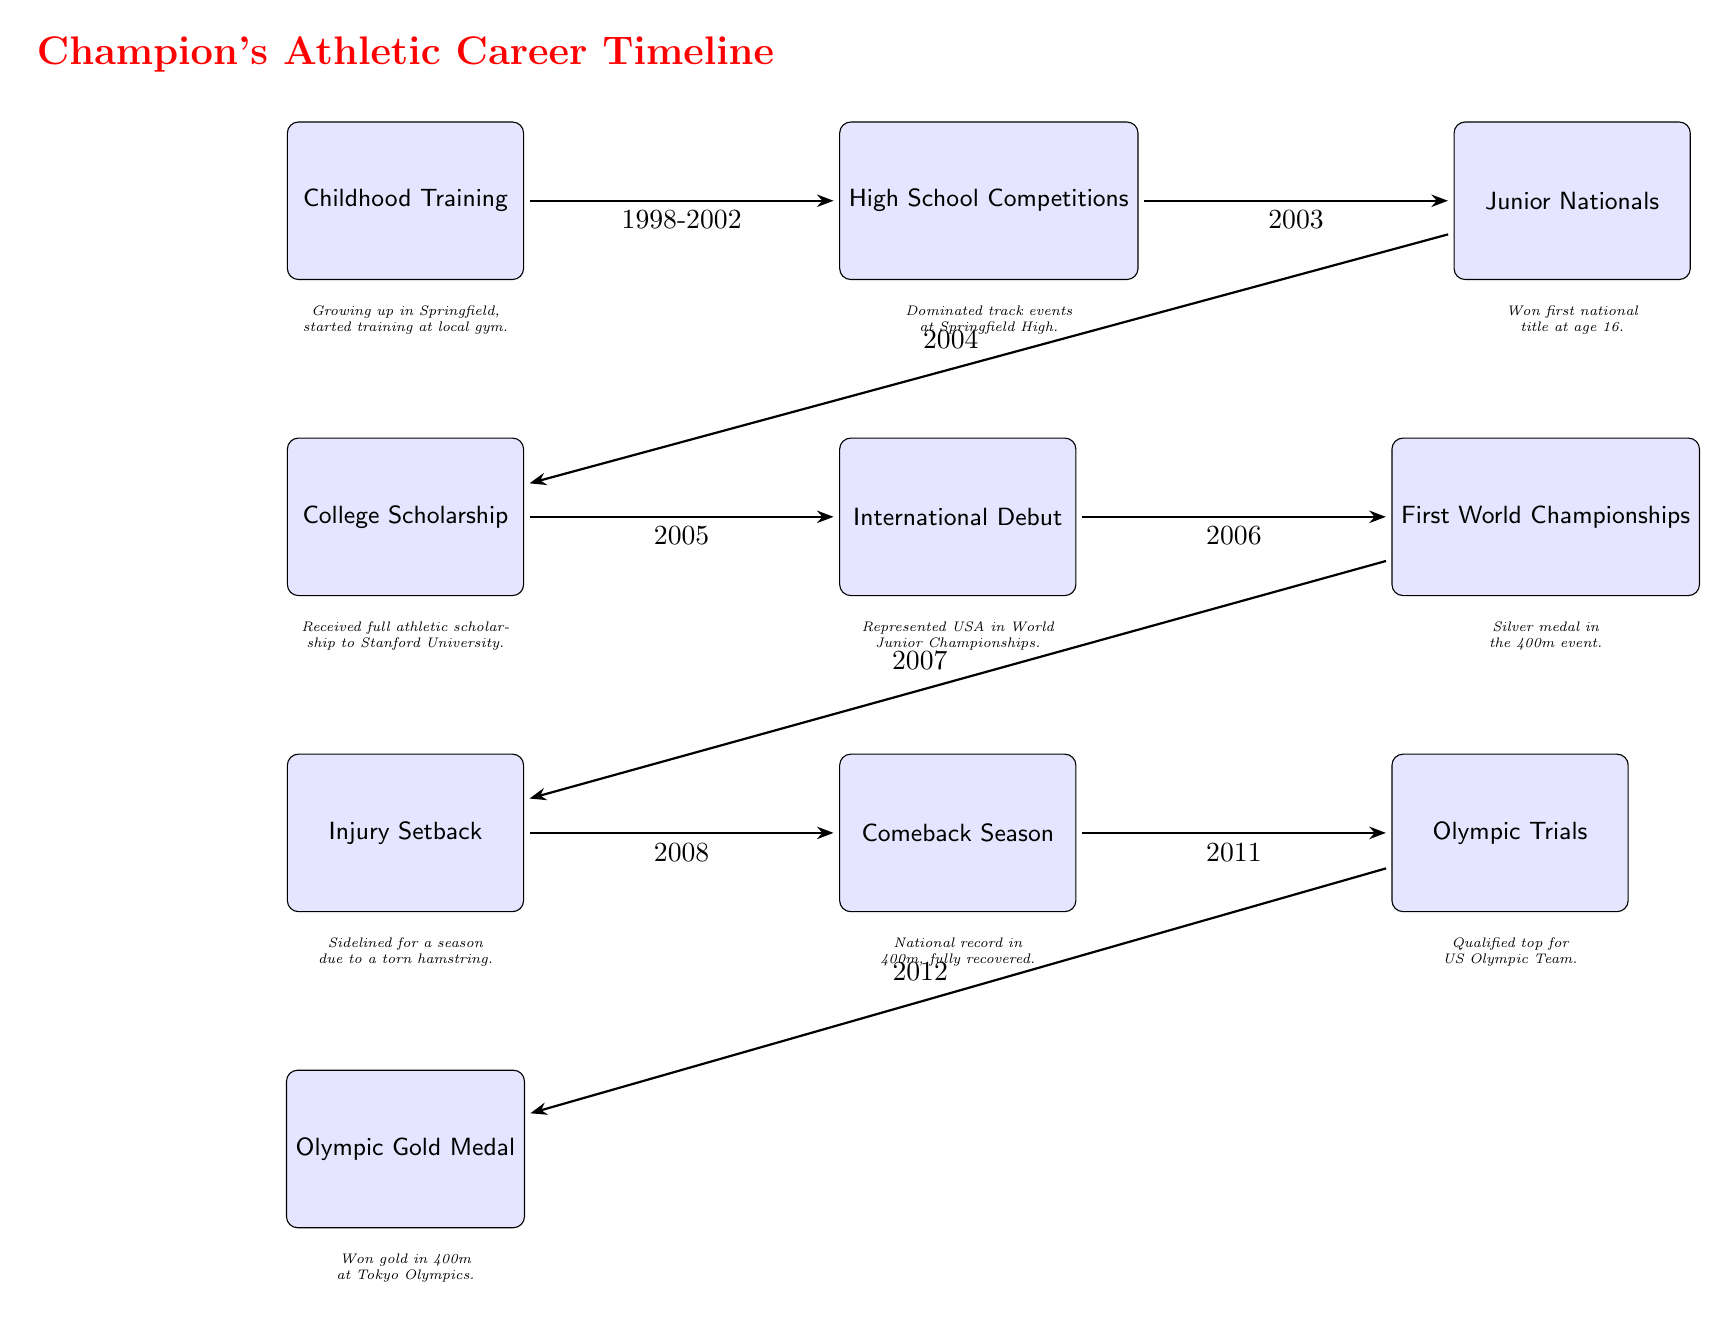What's the first notable event in the timeline? The diagram starts with "Childhood Training" as the first event.
Answer: Childhood Training How many major events are depicted in the timeline? There are a total of 10 major events listed from childhood training to the Olympic gold medal.
Answer: 10 What year did the champion participate in their first World Championships? The line connecting "International Debut" and "First World Championships" shows that the champion participated in the World Championships in 2006.
Answer: 2006 After which event did the champion face an injury setback? The line from "First World Championships" to "Injury Setback" indicates that the injury setback occurred after the champion won a silver medal in 2006.
Answer: After the First World Championships What significant achievement happened in 2012? In 2012, the champion won the Olympic Gold Medal, marking the culmination of their journey on this timeline.
Answer: Olympic Gold Medal Which event immediately followed the Comeback Season? The event "Olympic Trials" directly follows "Comeback Season" as the next major milestone in the timeline.
Answer: Olympic Trials What is the relationship between "Junior Nationals" and "High School Competitions"? "Junior Nationals" follows "High School Competitions" as the next event in the timeline, indicating the competitive progression from high school to national events.
Answer: Progression from High School to Junior Nationals What event occurred in 2005? The data shows that in 2005, the champion made their international debut, representing the USA.
Answer: International Debut What does the champion accomplish at the Junior Nationals? The champion won their first national title at age 16 during the Junior Nationals.
Answer: Won first national title 